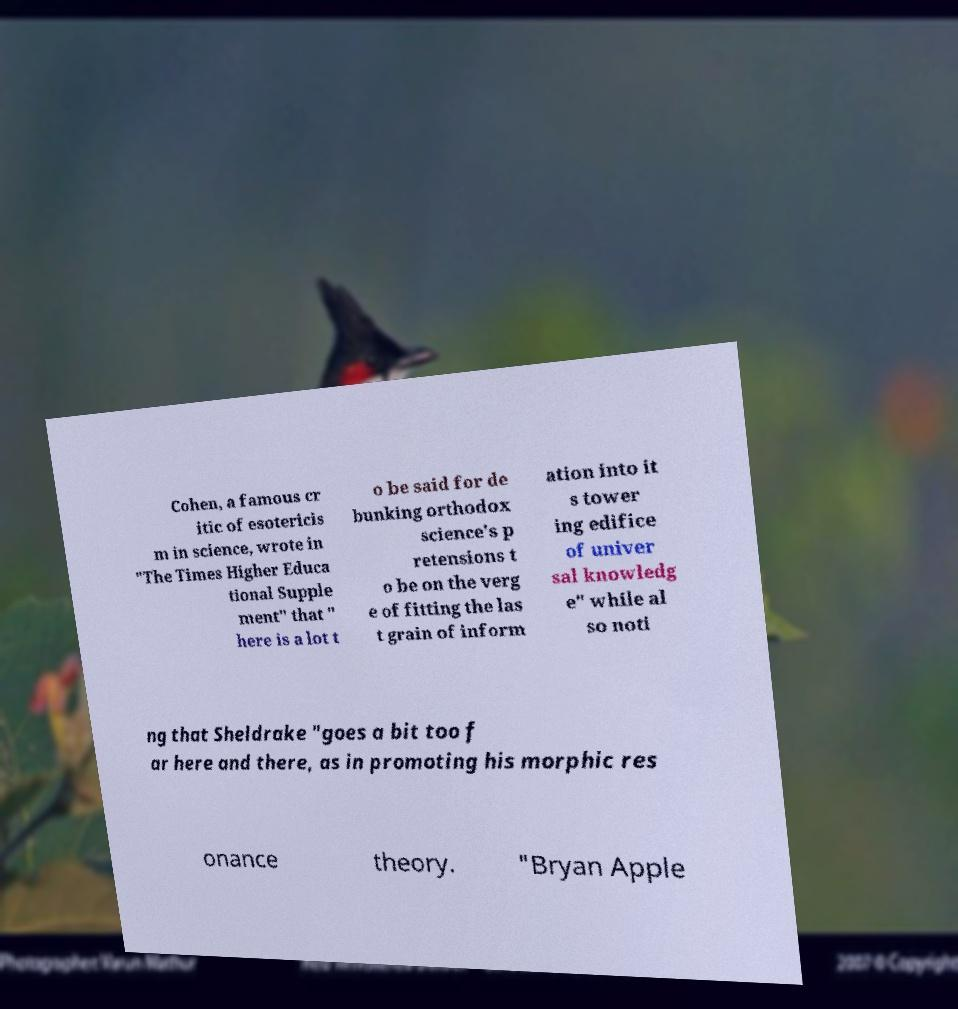Could you extract and type out the text from this image? Cohen, a famous cr itic of esotericis m in science, wrote in "The Times Higher Educa tional Supple ment" that " here is a lot t o be said for de bunking orthodox science's p retensions t o be on the verg e of fitting the las t grain of inform ation into it s tower ing edifice of univer sal knowledg e" while al so noti ng that Sheldrake "goes a bit too f ar here and there, as in promoting his morphic res onance theory. "Bryan Apple 